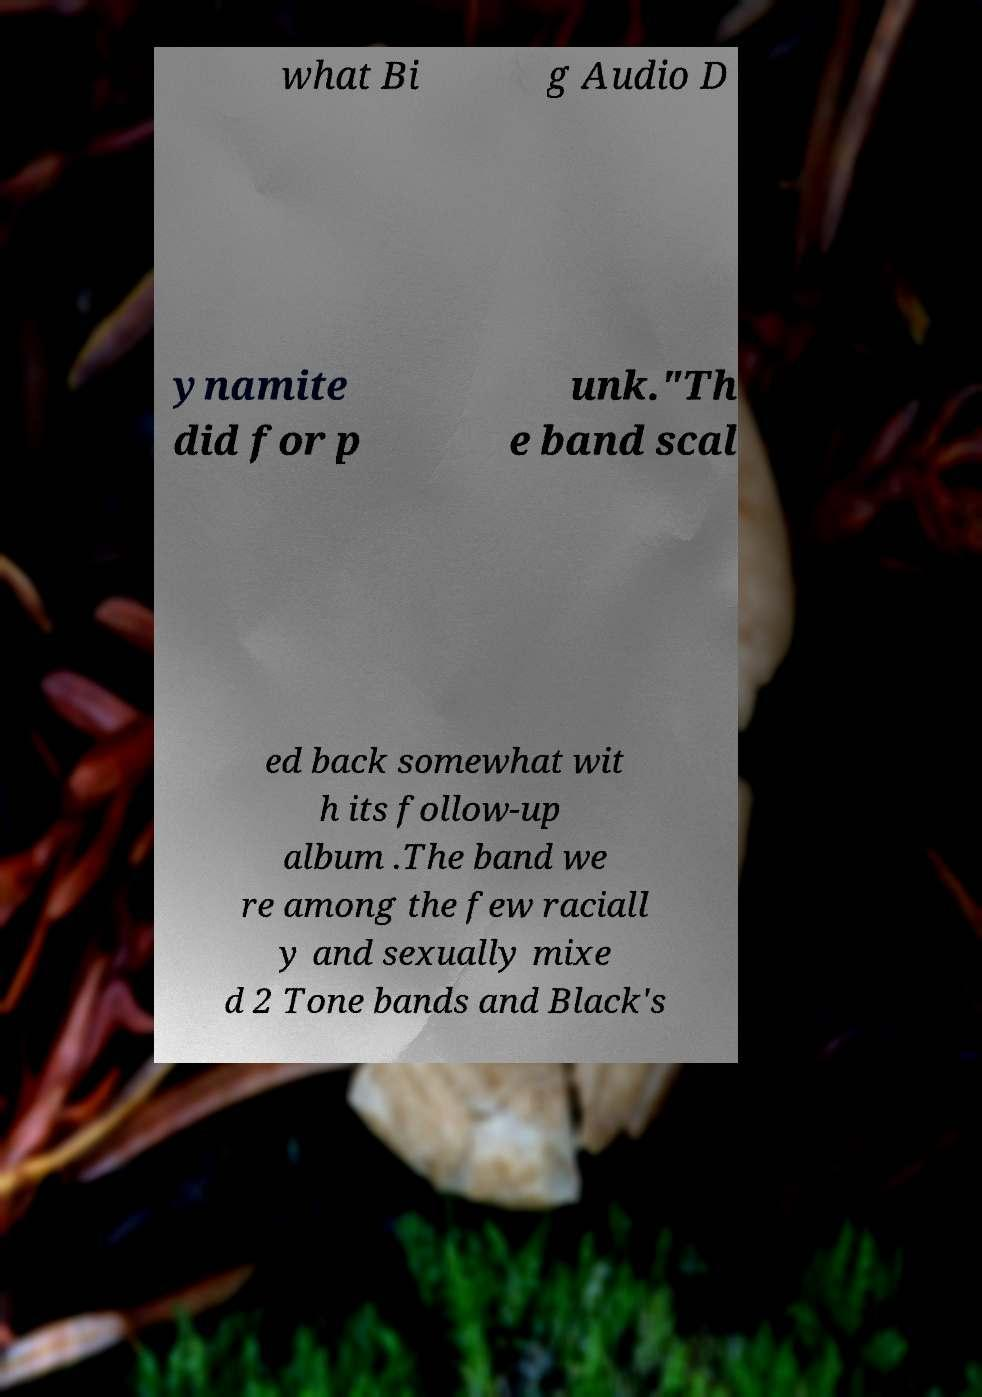Please read and relay the text visible in this image. What does it say? what Bi g Audio D ynamite did for p unk."Th e band scal ed back somewhat wit h its follow-up album .The band we re among the few raciall y and sexually mixe d 2 Tone bands and Black's 